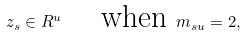<formula> <loc_0><loc_0><loc_500><loc_500>z _ { s } \in R ^ { u } \quad \text { when } m _ { s u } = 2 ,</formula> 